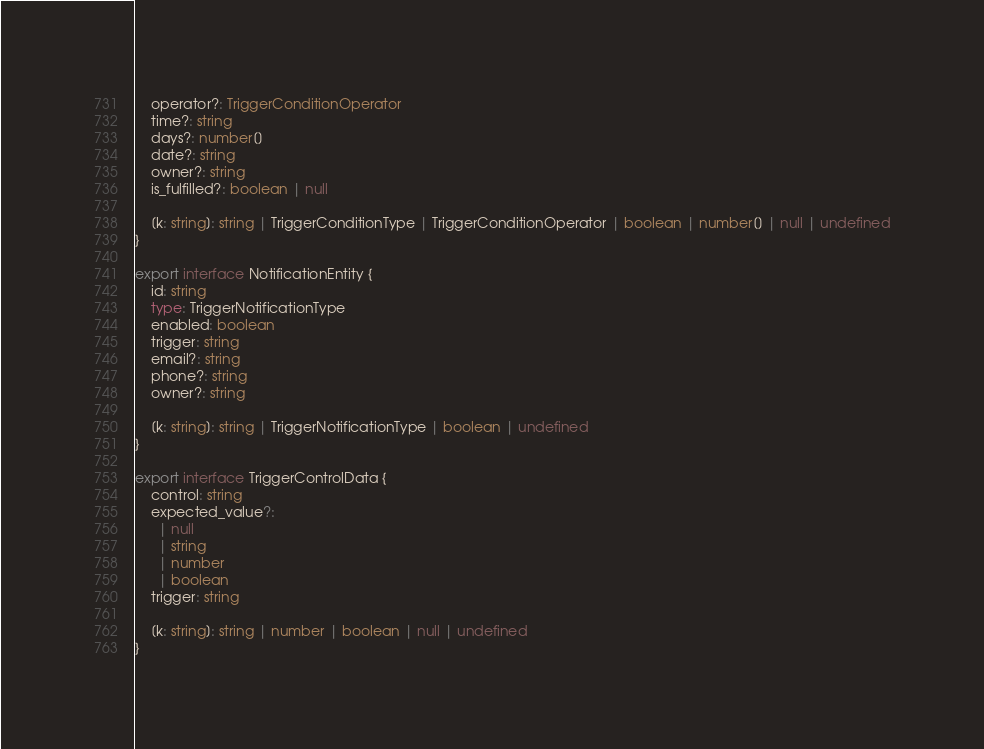Convert code to text. <code><loc_0><loc_0><loc_500><loc_500><_TypeScript_>    operator?: TriggerConditionOperator
    time?: string
    days?: number[]
    date?: string
    owner?: string
    is_fulfilled?: boolean | null

    [k: string]: string | TriggerConditionType | TriggerConditionOperator | boolean | number[] | null | undefined
}

export interface NotificationEntity {
    id: string
    type: TriggerNotificationType
    enabled: boolean
    trigger: string
    email?: string
    phone?: string
    owner?: string

    [k: string]: string | TriggerNotificationType | boolean | undefined
}

export interface TriggerControlData {
    control: string
    expected_value?:
      | null
      | string
      | number
      | boolean
    trigger: string

    [k: string]: string | number | boolean | null | undefined
}
</code> 